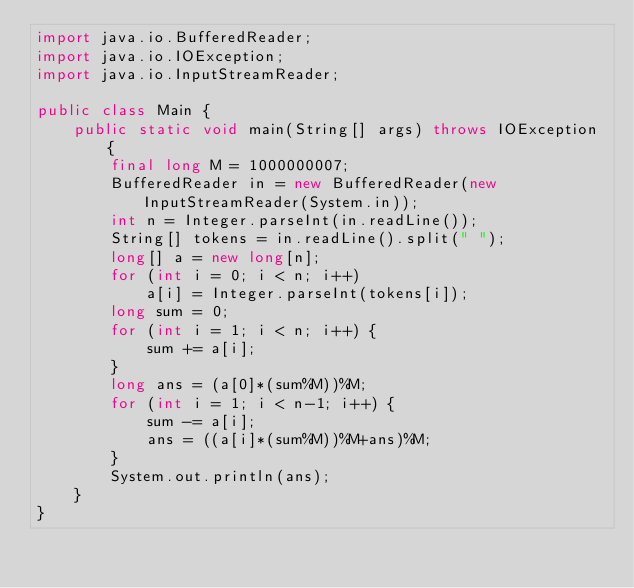Convert code to text. <code><loc_0><loc_0><loc_500><loc_500><_Java_>import java.io.BufferedReader;
import java.io.IOException;
import java.io.InputStreamReader;

public class Main {
	public static void main(String[] args) throws IOException {
		final long M = 1000000007;
		BufferedReader in = new BufferedReader(new InputStreamReader(System.in));
		int n = Integer.parseInt(in.readLine());
		String[] tokens = in.readLine().split(" ");
		long[] a = new long[n];
		for (int i = 0; i < n; i++)
			a[i] = Integer.parseInt(tokens[i]);
		long sum = 0;
		for (int i = 1; i < n; i++) {
			sum += a[i];
		}
		long ans = (a[0]*(sum%M))%M;
		for (int i = 1; i < n-1; i++) {
			sum -= a[i];
			ans = ((a[i]*(sum%M))%M+ans)%M;
		}
		System.out.println(ans);
	}
}
</code> 